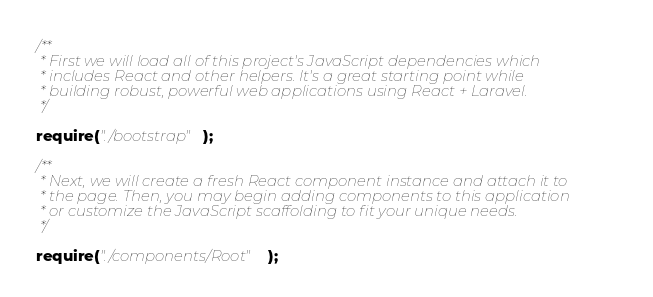<code> <loc_0><loc_0><loc_500><loc_500><_JavaScript_>/**
 * First we will load all of this project's JavaScript dependencies which
 * includes React and other helpers. It's a great starting point while
 * building robust, powerful web applications using React + Laravel.
 */

require("./bootstrap");

/**
 * Next, we will create a fresh React component instance and attach it to
 * the page. Then, you may begin adding components to this application
 * or customize the JavaScript scaffolding to fit your unique needs.
 */

require("./components/Root");
</code> 